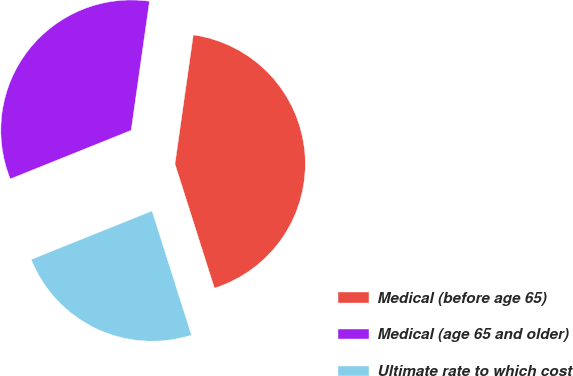Convert chart. <chart><loc_0><loc_0><loc_500><loc_500><pie_chart><fcel>Medical (before age 65)<fcel>Medical (age 65 and older)<fcel>Ultimate rate to which cost<nl><fcel>42.86%<fcel>33.33%<fcel>23.81%<nl></chart> 